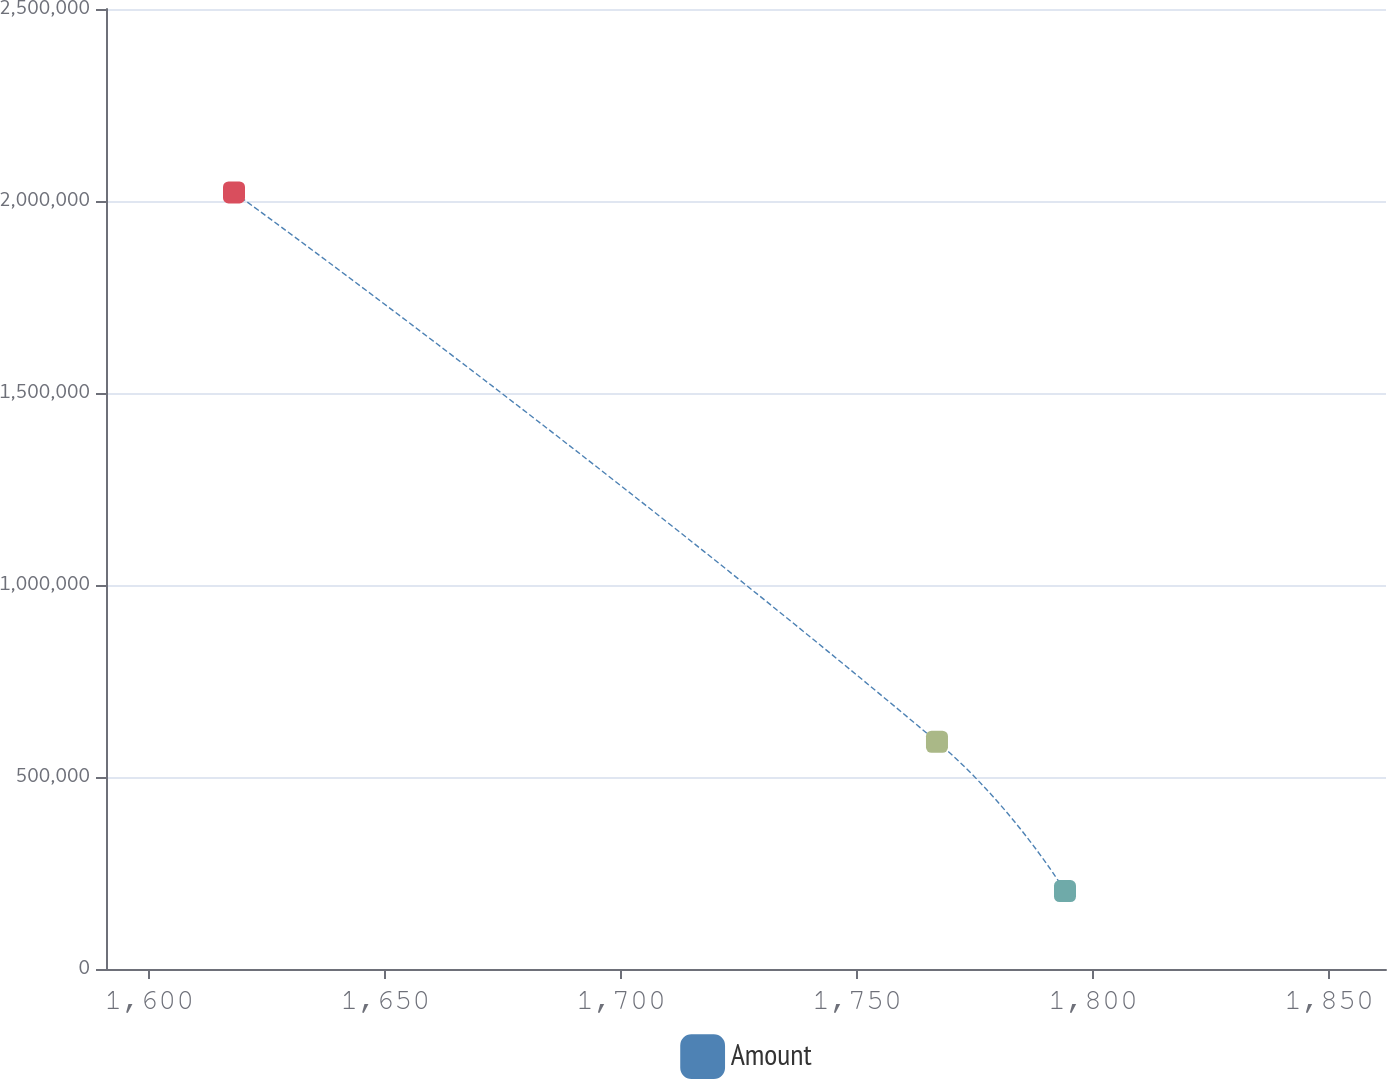<chart> <loc_0><loc_0><loc_500><loc_500><line_chart><ecel><fcel>Amount<nl><fcel>1617.97<fcel>2.02244e+06<nl><fcel>1766.94<fcel>591799<nl><fcel>1794.07<fcel>202837<nl><fcel>1889.22<fcel>659.04<nl></chart> 